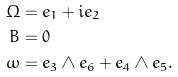Convert formula to latex. <formula><loc_0><loc_0><loc_500><loc_500>\Omega & = e _ { 1 } + i e _ { 2 } \\ B & = 0 \\ \omega & = e _ { 3 } \wedge e _ { 6 } + e _ { 4 } \wedge e _ { 5 } .</formula> 